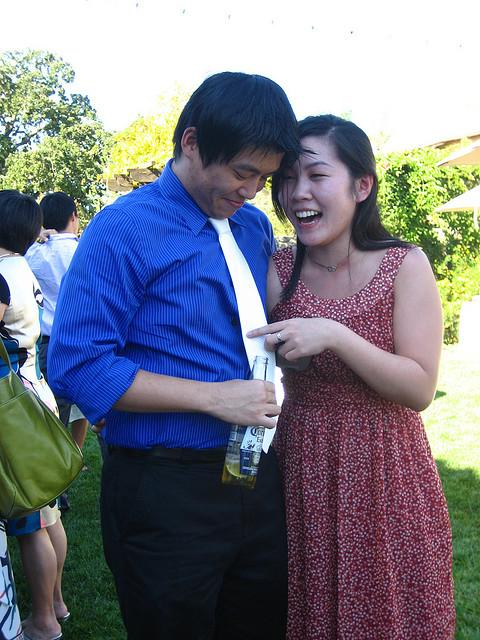How are the two people related?

Choices:
A) coworkers
B) classmates
C) lovers
D) siblings lovers 